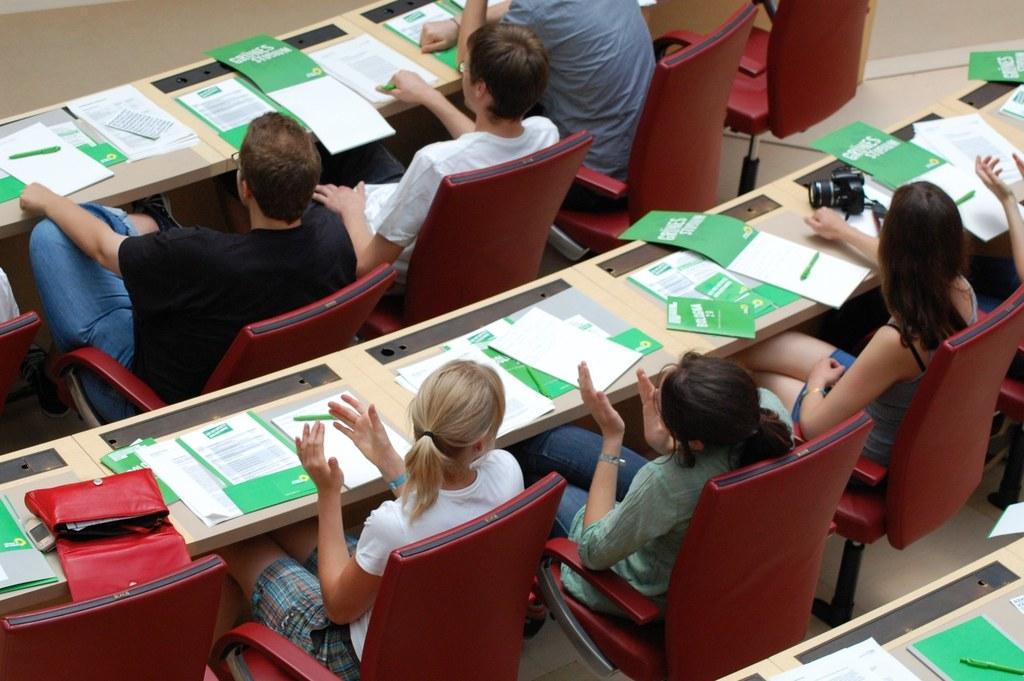How would you summarize this image in a sentence or two? In the image we can see few persons were sitting on the chair around the table. On table we can see books,pens,handbag,camera etc. 